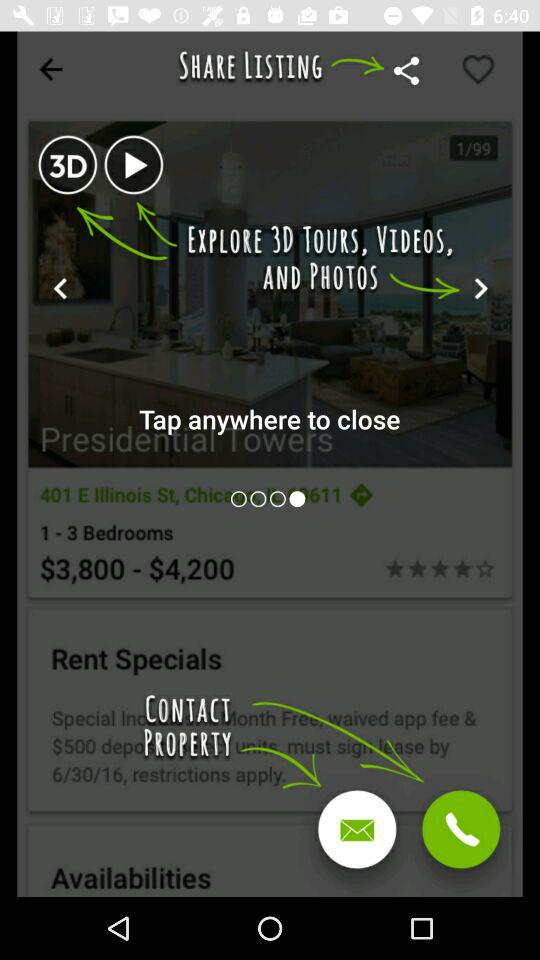What is the address of the Presidential Tower?
When the provided information is insufficient, respond with <no answer>. <no answer> 